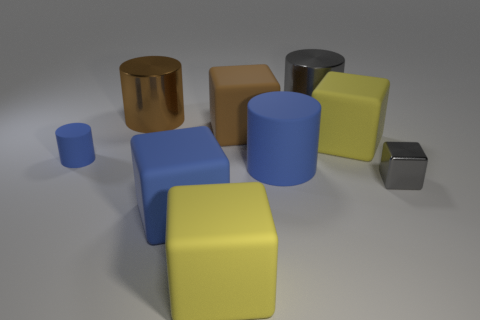Subtract all tiny rubber cylinders. How many cylinders are left? 3 Subtract all blue cylinders. How many cylinders are left? 2 Subtract all blocks. How many objects are left? 4 Subtract 3 blocks. How many blocks are left? 2 Add 1 tiny gray metal cubes. How many objects exist? 10 Add 1 cyan shiny cylinders. How many cyan shiny cylinders exist? 1 Subtract 0 red spheres. How many objects are left? 9 Subtract all yellow blocks. Subtract all brown balls. How many blocks are left? 3 Subtract all red cylinders. How many blue cubes are left? 1 Subtract all big yellow rubber blocks. Subtract all big brown rubber cubes. How many objects are left? 6 